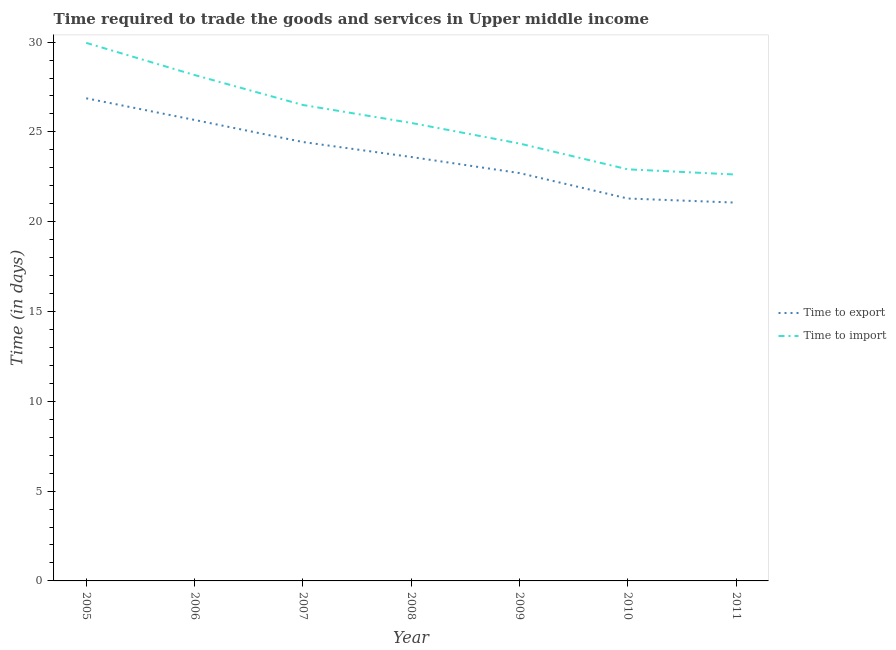How many different coloured lines are there?
Provide a short and direct response. 2. Is the number of lines equal to the number of legend labels?
Give a very brief answer. Yes. What is the time to export in 2008?
Offer a very short reply. 23.6. Across all years, what is the maximum time to import?
Your answer should be very brief. 29.96. Across all years, what is the minimum time to import?
Provide a succinct answer. 22.62. In which year was the time to import minimum?
Keep it short and to the point. 2011. What is the total time to import in the graph?
Provide a short and direct response. 180.02. What is the difference between the time to import in 2007 and that in 2011?
Ensure brevity in your answer.  3.88. What is the difference between the time to import in 2007 and the time to export in 2005?
Provide a succinct answer. -0.37. What is the average time to export per year?
Offer a terse response. 23.66. In the year 2010, what is the difference between the time to import and time to export?
Offer a very short reply. 1.62. In how many years, is the time to import greater than 29 days?
Provide a short and direct response. 1. What is the ratio of the time to import in 2007 to that in 2009?
Offer a very short reply. 1.09. What is the difference between the highest and the second highest time to import?
Your answer should be compact. 1.79. What is the difference between the highest and the lowest time to export?
Make the answer very short. 5.81. In how many years, is the time to export greater than the average time to export taken over all years?
Give a very brief answer. 3. Is the sum of the time to export in 2006 and 2007 greater than the maximum time to import across all years?
Your answer should be very brief. Yes. Is the time to export strictly greater than the time to import over the years?
Provide a short and direct response. No. How many years are there in the graph?
Your answer should be compact. 7. What is the difference between two consecutive major ticks on the Y-axis?
Offer a terse response. 5. Are the values on the major ticks of Y-axis written in scientific E-notation?
Offer a very short reply. No. Does the graph contain any zero values?
Give a very brief answer. No. Does the graph contain grids?
Your answer should be very brief. No. How are the legend labels stacked?
Provide a succinct answer. Vertical. What is the title of the graph?
Keep it short and to the point. Time required to trade the goods and services in Upper middle income. What is the label or title of the X-axis?
Your answer should be very brief. Year. What is the label or title of the Y-axis?
Keep it short and to the point. Time (in days). What is the Time (in days) in Time to export in 2005?
Your answer should be compact. 26.87. What is the Time (in days) of Time to import in 2005?
Your response must be concise. 29.96. What is the Time (in days) of Time to export in 2006?
Keep it short and to the point. 25.67. What is the Time (in days) of Time to import in 2006?
Offer a very short reply. 28.17. What is the Time (in days) of Time to export in 2007?
Offer a terse response. 24.44. What is the Time (in days) of Time to import in 2007?
Your answer should be very brief. 26.5. What is the Time (in days) of Time to export in 2008?
Make the answer very short. 23.6. What is the Time (in days) in Time to import in 2008?
Provide a succinct answer. 25.5. What is the Time (in days) of Time to export in 2009?
Keep it short and to the point. 22.71. What is the Time (in days) in Time to import in 2009?
Make the answer very short. 24.35. What is the Time (in days) in Time to export in 2010?
Make the answer very short. 21.29. What is the Time (in days) of Time to import in 2010?
Give a very brief answer. 22.92. What is the Time (in days) in Time to export in 2011?
Offer a very short reply. 21.06. What is the Time (in days) of Time to import in 2011?
Keep it short and to the point. 22.62. Across all years, what is the maximum Time (in days) of Time to export?
Your response must be concise. 26.87. Across all years, what is the maximum Time (in days) in Time to import?
Your answer should be very brief. 29.96. Across all years, what is the minimum Time (in days) of Time to export?
Offer a terse response. 21.06. Across all years, what is the minimum Time (in days) in Time to import?
Offer a terse response. 22.62. What is the total Time (in days) in Time to export in the graph?
Your response must be concise. 165.64. What is the total Time (in days) of Time to import in the graph?
Your answer should be compact. 180.02. What is the difference between the Time (in days) of Time to export in 2005 and that in 2006?
Ensure brevity in your answer.  1.21. What is the difference between the Time (in days) in Time to import in 2005 and that in 2006?
Your answer should be compact. 1.79. What is the difference between the Time (in days) in Time to export in 2005 and that in 2007?
Ensure brevity in your answer.  2.43. What is the difference between the Time (in days) in Time to import in 2005 and that in 2007?
Ensure brevity in your answer.  3.46. What is the difference between the Time (in days) in Time to export in 2005 and that in 2008?
Offer a very short reply. 3.27. What is the difference between the Time (in days) of Time to import in 2005 and that in 2008?
Offer a very short reply. 4.46. What is the difference between the Time (in days) in Time to export in 2005 and that in 2009?
Give a very brief answer. 4.16. What is the difference between the Time (in days) of Time to import in 2005 and that in 2009?
Keep it short and to the point. 5.6. What is the difference between the Time (in days) of Time to export in 2005 and that in 2010?
Provide a succinct answer. 5.58. What is the difference between the Time (in days) of Time to import in 2005 and that in 2010?
Provide a short and direct response. 7.04. What is the difference between the Time (in days) in Time to export in 2005 and that in 2011?
Give a very brief answer. 5.81. What is the difference between the Time (in days) of Time to import in 2005 and that in 2011?
Provide a succinct answer. 7.33. What is the difference between the Time (in days) of Time to export in 2006 and that in 2007?
Keep it short and to the point. 1.23. What is the difference between the Time (in days) of Time to export in 2006 and that in 2008?
Your answer should be compact. 2.06. What is the difference between the Time (in days) of Time to import in 2006 and that in 2008?
Provide a succinct answer. 2.67. What is the difference between the Time (in days) in Time to export in 2006 and that in 2009?
Offer a very short reply. 2.96. What is the difference between the Time (in days) of Time to import in 2006 and that in 2009?
Provide a succinct answer. 3.81. What is the difference between the Time (in days) in Time to export in 2006 and that in 2010?
Provide a short and direct response. 4.38. What is the difference between the Time (in days) in Time to import in 2006 and that in 2010?
Provide a short and direct response. 5.25. What is the difference between the Time (in days) of Time to export in 2006 and that in 2011?
Make the answer very short. 4.6. What is the difference between the Time (in days) of Time to import in 2006 and that in 2011?
Your response must be concise. 5.54. What is the difference between the Time (in days) of Time to export in 2007 and that in 2008?
Keep it short and to the point. 0.83. What is the difference between the Time (in days) in Time to export in 2007 and that in 2009?
Provide a succinct answer. 1.73. What is the difference between the Time (in days) in Time to import in 2007 and that in 2009?
Your answer should be very brief. 2.15. What is the difference between the Time (in days) of Time to export in 2007 and that in 2010?
Keep it short and to the point. 3.15. What is the difference between the Time (in days) in Time to import in 2007 and that in 2010?
Keep it short and to the point. 3.58. What is the difference between the Time (in days) of Time to export in 2007 and that in 2011?
Your answer should be very brief. 3.38. What is the difference between the Time (in days) of Time to import in 2007 and that in 2011?
Make the answer very short. 3.88. What is the difference between the Time (in days) in Time to export in 2008 and that in 2009?
Keep it short and to the point. 0.9. What is the difference between the Time (in days) of Time to import in 2008 and that in 2009?
Ensure brevity in your answer.  1.15. What is the difference between the Time (in days) of Time to export in 2008 and that in 2010?
Provide a succinct answer. 2.31. What is the difference between the Time (in days) in Time to import in 2008 and that in 2010?
Offer a terse response. 2.58. What is the difference between the Time (in days) of Time to export in 2008 and that in 2011?
Your response must be concise. 2.54. What is the difference between the Time (in days) of Time to import in 2008 and that in 2011?
Offer a very short reply. 2.88. What is the difference between the Time (in days) of Time to export in 2009 and that in 2010?
Your answer should be compact. 1.42. What is the difference between the Time (in days) of Time to import in 2009 and that in 2010?
Provide a succinct answer. 1.44. What is the difference between the Time (in days) in Time to export in 2009 and that in 2011?
Your answer should be compact. 1.65. What is the difference between the Time (in days) of Time to import in 2009 and that in 2011?
Your answer should be very brief. 1.73. What is the difference between the Time (in days) of Time to export in 2010 and that in 2011?
Provide a short and direct response. 0.23. What is the difference between the Time (in days) in Time to import in 2010 and that in 2011?
Give a very brief answer. 0.29. What is the difference between the Time (in days) in Time to export in 2005 and the Time (in days) in Time to import in 2006?
Provide a short and direct response. -1.29. What is the difference between the Time (in days) of Time to export in 2005 and the Time (in days) of Time to import in 2007?
Ensure brevity in your answer.  0.37. What is the difference between the Time (in days) in Time to export in 2005 and the Time (in days) in Time to import in 2008?
Give a very brief answer. 1.37. What is the difference between the Time (in days) of Time to export in 2005 and the Time (in days) of Time to import in 2009?
Provide a short and direct response. 2.52. What is the difference between the Time (in days) of Time to export in 2005 and the Time (in days) of Time to import in 2010?
Offer a very short reply. 3.96. What is the difference between the Time (in days) of Time to export in 2005 and the Time (in days) of Time to import in 2011?
Your answer should be compact. 4.25. What is the difference between the Time (in days) in Time to export in 2006 and the Time (in days) in Time to import in 2007?
Give a very brief answer. -0.83. What is the difference between the Time (in days) in Time to export in 2006 and the Time (in days) in Time to import in 2009?
Provide a short and direct response. 1.31. What is the difference between the Time (in days) of Time to export in 2006 and the Time (in days) of Time to import in 2010?
Offer a terse response. 2.75. What is the difference between the Time (in days) in Time to export in 2006 and the Time (in days) in Time to import in 2011?
Your answer should be very brief. 3.04. What is the difference between the Time (in days) of Time to export in 2007 and the Time (in days) of Time to import in 2008?
Offer a terse response. -1.06. What is the difference between the Time (in days) in Time to export in 2007 and the Time (in days) in Time to import in 2009?
Your response must be concise. 0.08. What is the difference between the Time (in days) of Time to export in 2007 and the Time (in days) of Time to import in 2010?
Keep it short and to the point. 1.52. What is the difference between the Time (in days) of Time to export in 2007 and the Time (in days) of Time to import in 2011?
Make the answer very short. 1.81. What is the difference between the Time (in days) in Time to export in 2008 and the Time (in days) in Time to import in 2009?
Provide a short and direct response. -0.75. What is the difference between the Time (in days) in Time to export in 2008 and the Time (in days) in Time to import in 2010?
Your response must be concise. 0.69. What is the difference between the Time (in days) in Time to export in 2008 and the Time (in days) in Time to import in 2011?
Provide a succinct answer. 0.98. What is the difference between the Time (in days) of Time to export in 2009 and the Time (in days) of Time to import in 2010?
Your response must be concise. -0.21. What is the difference between the Time (in days) of Time to export in 2009 and the Time (in days) of Time to import in 2011?
Make the answer very short. 0.08. What is the difference between the Time (in days) in Time to export in 2010 and the Time (in days) in Time to import in 2011?
Ensure brevity in your answer.  -1.33. What is the average Time (in days) of Time to export per year?
Offer a very short reply. 23.66. What is the average Time (in days) of Time to import per year?
Your answer should be compact. 25.72. In the year 2005, what is the difference between the Time (in days) in Time to export and Time (in days) in Time to import?
Ensure brevity in your answer.  -3.09. In the year 2006, what is the difference between the Time (in days) of Time to export and Time (in days) of Time to import?
Your answer should be very brief. -2.5. In the year 2007, what is the difference between the Time (in days) in Time to export and Time (in days) in Time to import?
Give a very brief answer. -2.06. In the year 2008, what is the difference between the Time (in days) of Time to export and Time (in days) of Time to import?
Offer a terse response. -1.9. In the year 2009, what is the difference between the Time (in days) of Time to export and Time (in days) of Time to import?
Make the answer very short. -1.65. In the year 2010, what is the difference between the Time (in days) in Time to export and Time (in days) in Time to import?
Ensure brevity in your answer.  -1.62. In the year 2011, what is the difference between the Time (in days) in Time to export and Time (in days) in Time to import?
Give a very brief answer. -1.56. What is the ratio of the Time (in days) of Time to export in 2005 to that in 2006?
Provide a short and direct response. 1.05. What is the ratio of the Time (in days) in Time to import in 2005 to that in 2006?
Your answer should be compact. 1.06. What is the ratio of the Time (in days) of Time to export in 2005 to that in 2007?
Give a very brief answer. 1.1. What is the ratio of the Time (in days) in Time to import in 2005 to that in 2007?
Your response must be concise. 1.13. What is the ratio of the Time (in days) in Time to export in 2005 to that in 2008?
Provide a short and direct response. 1.14. What is the ratio of the Time (in days) in Time to import in 2005 to that in 2008?
Your answer should be compact. 1.17. What is the ratio of the Time (in days) in Time to export in 2005 to that in 2009?
Keep it short and to the point. 1.18. What is the ratio of the Time (in days) in Time to import in 2005 to that in 2009?
Offer a very short reply. 1.23. What is the ratio of the Time (in days) of Time to export in 2005 to that in 2010?
Your response must be concise. 1.26. What is the ratio of the Time (in days) of Time to import in 2005 to that in 2010?
Offer a very short reply. 1.31. What is the ratio of the Time (in days) in Time to export in 2005 to that in 2011?
Give a very brief answer. 1.28. What is the ratio of the Time (in days) of Time to import in 2005 to that in 2011?
Offer a very short reply. 1.32. What is the ratio of the Time (in days) in Time to export in 2006 to that in 2007?
Ensure brevity in your answer.  1.05. What is the ratio of the Time (in days) in Time to import in 2006 to that in 2007?
Your answer should be compact. 1.06. What is the ratio of the Time (in days) in Time to export in 2006 to that in 2008?
Provide a short and direct response. 1.09. What is the ratio of the Time (in days) of Time to import in 2006 to that in 2008?
Ensure brevity in your answer.  1.1. What is the ratio of the Time (in days) of Time to export in 2006 to that in 2009?
Offer a terse response. 1.13. What is the ratio of the Time (in days) of Time to import in 2006 to that in 2009?
Offer a terse response. 1.16. What is the ratio of the Time (in days) in Time to export in 2006 to that in 2010?
Offer a very short reply. 1.21. What is the ratio of the Time (in days) of Time to import in 2006 to that in 2010?
Provide a succinct answer. 1.23. What is the ratio of the Time (in days) of Time to export in 2006 to that in 2011?
Offer a very short reply. 1.22. What is the ratio of the Time (in days) in Time to import in 2006 to that in 2011?
Offer a very short reply. 1.24. What is the ratio of the Time (in days) of Time to export in 2007 to that in 2008?
Provide a succinct answer. 1.04. What is the ratio of the Time (in days) in Time to import in 2007 to that in 2008?
Give a very brief answer. 1.04. What is the ratio of the Time (in days) of Time to export in 2007 to that in 2009?
Ensure brevity in your answer.  1.08. What is the ratio of the Time (in days) of Time to import in 2007 to that in 2009?
Offer a terse response. 1.09. What is the ratio of the Time (in days) of Time to export in 2007 to that in 2010?
Give a very brief answer. 1.15. What is the ratio of the Time (in days) in Time to import in 2007 to that in 2010?
Provide a short and direct response. 1.16. What is the ratio of the Time (in days) of Time to export in 2007 to that in 2011?
Make the answer very short. 1.16. What is the ratio of the Time (in days) of Time to import in 2007 to that in 2011?
Keep it short and to the point. 1.17. What is the ratio of the Time (in days) of Time to export in 2008 to that in 2009?
Your answer should be very brief. 1.04. What is the ratio of the Time (in days) of Time to import in 2008 to that in 2009?
Your response must be concise. 1.05. What is the ratio of the Time (in days) of Time to export in 2008 to that in 2010?
Your response must be concise. 1.11. What is the ratio of the Time (in days) in Time to import in 2008 to that in 2010?
Offer a very short reply. 1.11. What is the ratio of the Time (in days) in Time to export in 2008 to that in 2011?
Offer a terse response. 1.12. What is the ratio of the Time (in days) of Time to import in 2008 to that in 2011?
Make the answer very short. 1.13. What is the ratio of the Time (in days) of Time to export in 2009 to that in 2010?
Offer a terse response. 1.07. What is the ratio of the Time (in days) of Time to import in 2009 to that in 2010?
Provide a short and direct response. 1.06. What is the ratio of the Time (in days) in Time to export in 2009 to that in 2011?
Give a very brief answer. 1.08. What is the ratio of the Time (in days) of Time to import in 2009 to that in 2011?
Provide a short and direct response. 1.08. What is the ratio of the Time (in days) in Time to export in 2010 to that in 2011?
Ensure brevity in your answer.  1.01. What is the ratio of the Time (in days) of Time to import in 2010 to that in 2011?
Offer a very short reply. 1.01. What is the difference between the highest and the second highest Time (in days) in Time to export?
Your answer should be compact. 1.21. What is the difference between the highest and the second highest Time (in days) of Time to import?
Your answer should be compact. 1.79. What is the difference between the highest and the lowest Time (in days) in Time to export?
Ensure brevity in your answer.  5.81. What is the difference between the highest and the lowest Time (in days) of Time to import?
Offer a terse response. 7.33. 